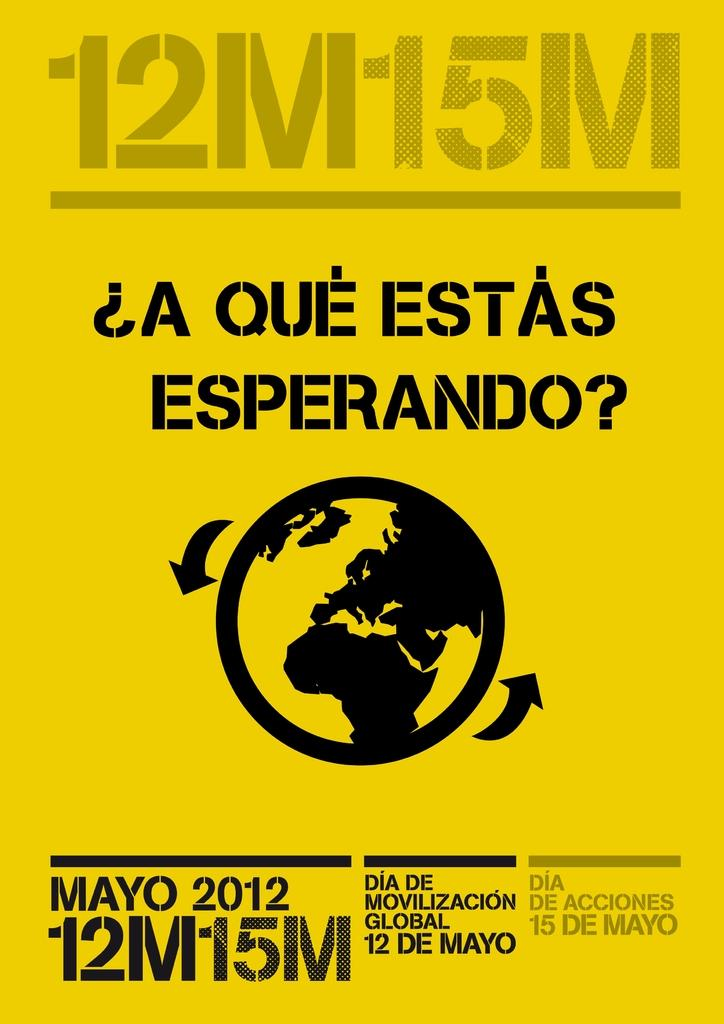Provide a one-sentence caption for the provided image. A poster is promoting a global mobilization day on May 12th, 2012. 